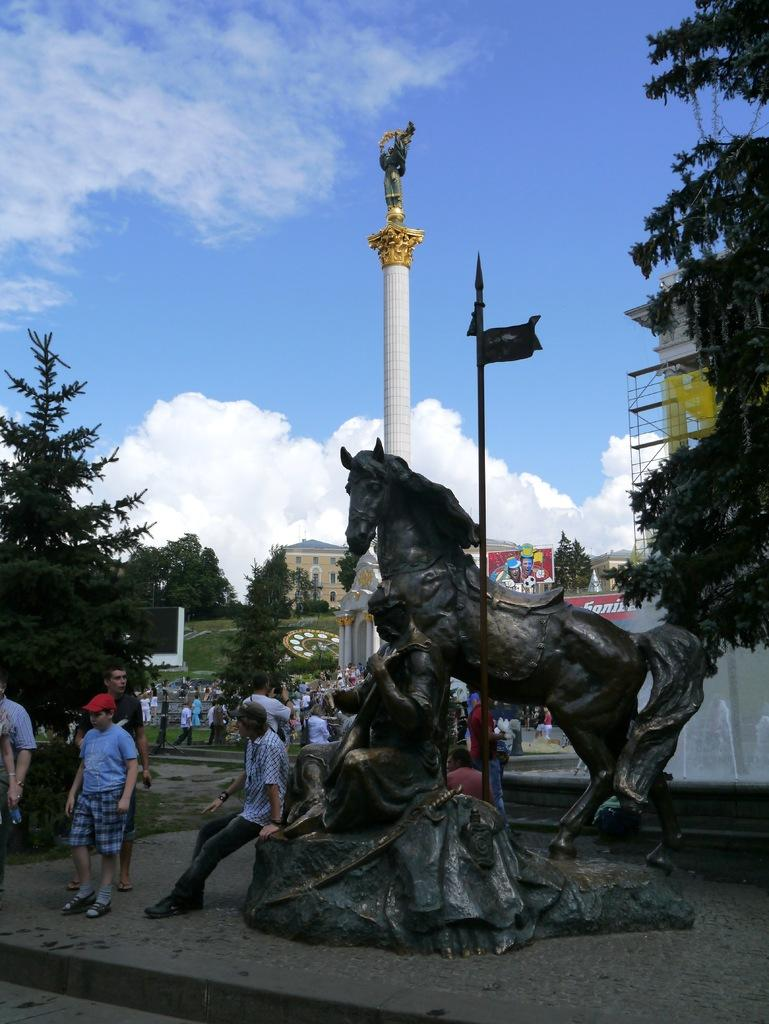What is the main subject in the image? There is a statue in the image. Are there any other subjects or objects in the image? Yes, there is a group of people in the image. What can be seen in the background of the image? There are trees, a tower, buildings, and clouds visible in the background of the image. How many cats are sitting on the seat in the image? There are no cats or seats present in the image. 